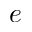Convert formula to latex. <formula><loc_0><loc_0><loc_500><loc_500>^ { e }</formula> 